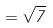Convert formula to latex. <formula><loc_0><loc_0><loc_500><loc_500>= \sqrt { 7 }</formula> 